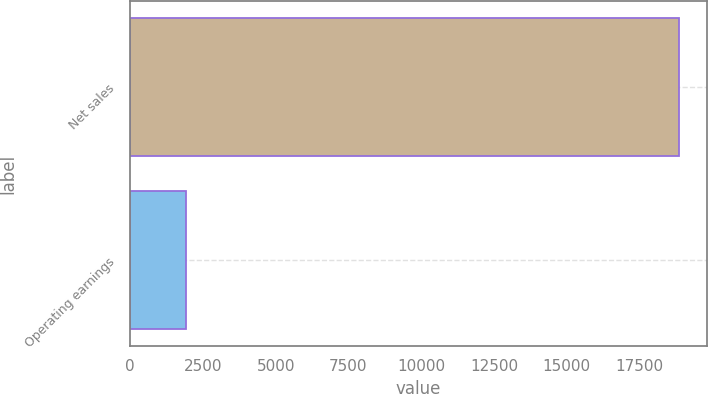Convert chart to OTSL. <chart><loc_0><loc_0><loc_500><loc_500><bar_chart><fcel>Net sales<fcel>Operating earnings<nl><fcel>18868<fcel>1931<nl></chart> 